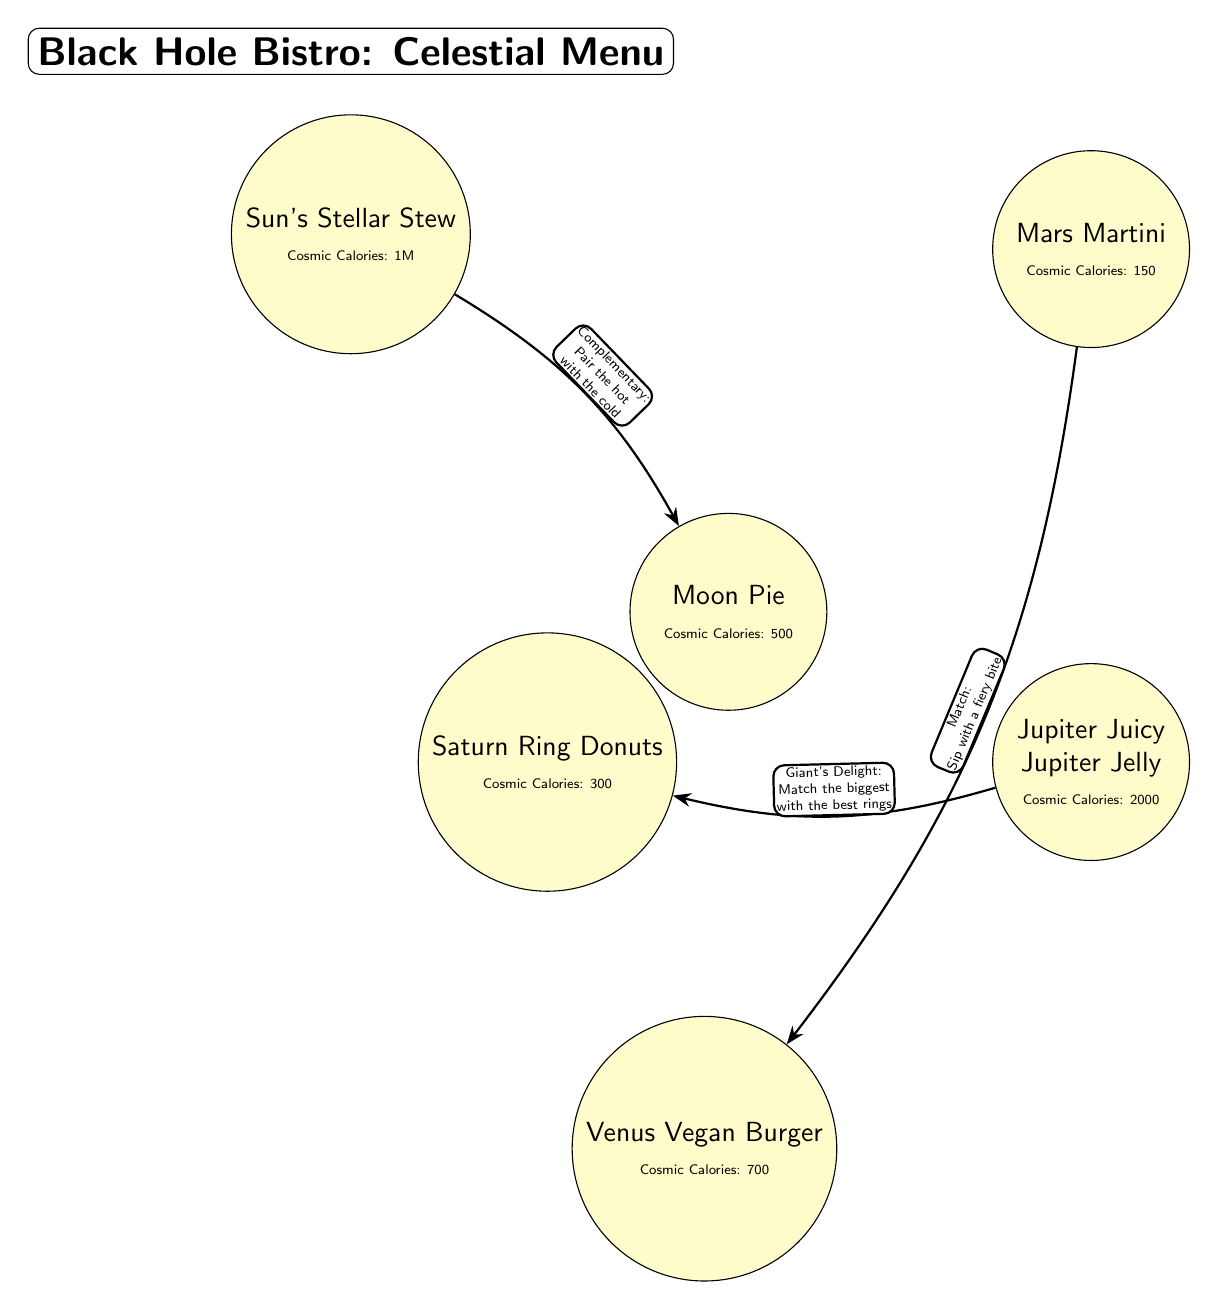What is the name of the dish associated with the Sun? The diagram shows that the dish related to the Sun is labeled as "Sun's Stellar Stew". This information is directly represented within the node that corresponds to the Sun.
Answer: Sun's Stellar Stew How many celestial dishes are listed in the diagram? By counting the nodes that represent different dishes, we find there are six distinct celestial dishes, including the Sun's Stellar Stew, Moon Pie, Mars Martini, Jupiter Juicy Jupiter Jelly, Venus Vegan Burger, and Saturn Ring Donuts.
Answer: 6 What is the cosmic calorie count for the Jupiter dish? The diagram specifies that the Jupiter dish has a cosmic calorie count of 2000, indicated in a smaller font below the dish's name within its node.
Answer: 2000 What complementary pairing is suggested between dishes? The edge labeled "Complementary: Pair the hot with the cold" connects the Sun's Stellar Stew and the Moon Pie, indicating that these two dishes are recommended to be paired together.
Answer: Pair the hot with the cold Which two dishes are connected by the edge labeled "Giant's Delight: Match the biggest with the best rings"? The edge with that label connects Jupiter Juicy Jupiter Jelly to Saturn Ring Donuts, suggesting this pairing for gastronomic delight according to their sizes and qualities.
Answer: Jupiter Juicy Jupiter Jelly and Saturn Ring Donuts What cosmic calorie count does the Moon Pie dish have? Within the Moon Pie node, it is stated that it has a cosmic calorie count of 500, which is directly quoted in its description in the diagram.
Answer: 500 Which dish is suggested to match a fiery drink according to its connection with Mars? Mars Martini is indicated to match the Venus Vegan Burger, as shown by the edge labeled "Match: Sip with a fiery bite" connecting the two dishes.
Answer: Venus Vegan Burger What type of dish is the Saturn Ring Donuts described as? According to the diagram, the Saturn dish is labeled as "Saturn Ring Donuts", indicating its nature as a donut-themed culinary item that creatively represents Saturn's rings.
Answer: Ring Donuts What is the underlying theme of the Black Hole Bistro menu? The overall theme is a fun, astronomical approach to naming and describing dishes based on celestial bodies, combining humor and food in a whimsical restaurant concept.
Answer: Celestial-themed humor 